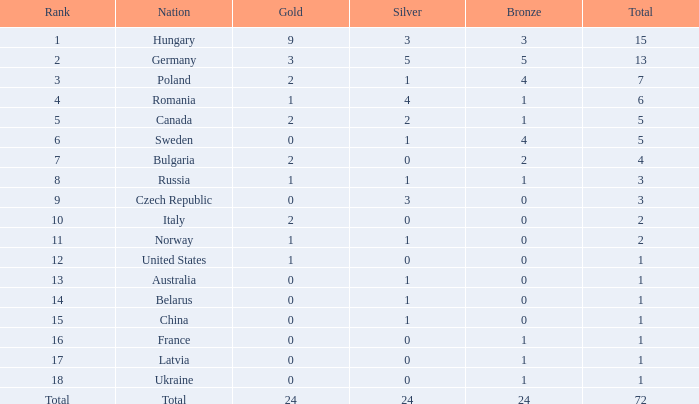How many golds have 3 as the position, with a sum greater than 7? 0.0. 